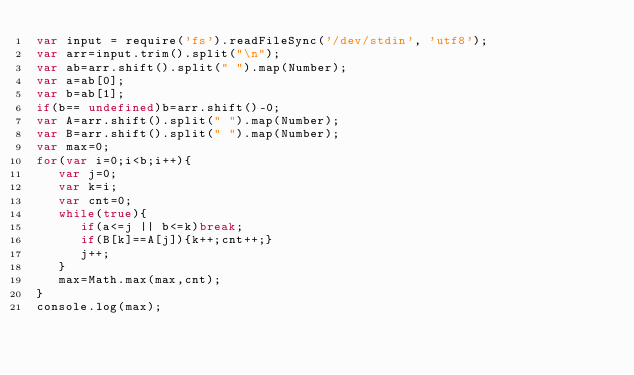Convert code to text. <code><loc_0><loc_0><loc_500><loc_500><_JavaScript_>var input = require('fs').readFileSync('/dev/stdin', 'utf8');
var arr=input.trim().split("\n");
var ab=arr.shift().split(" ").map(Number);
var a=ab[0];
var b=ab[1];
if(b== undefined)b=arr.shift()-0;
var A=arr.shift().split(" ").map(Number);
var B=arr.shift().split(" ").map(Number);
var max=0;
for(var i=0;i<b;i++){
   var j=0;
   var k=i;
   var cnt=0;
   while(true){
      if(a<=j || b<=k)break;
      if(B[k]==A[j]){k++;cnt++;}
      j++;
   }
   max=Math.max(max,cnt);
}
console.log(max);</code> 